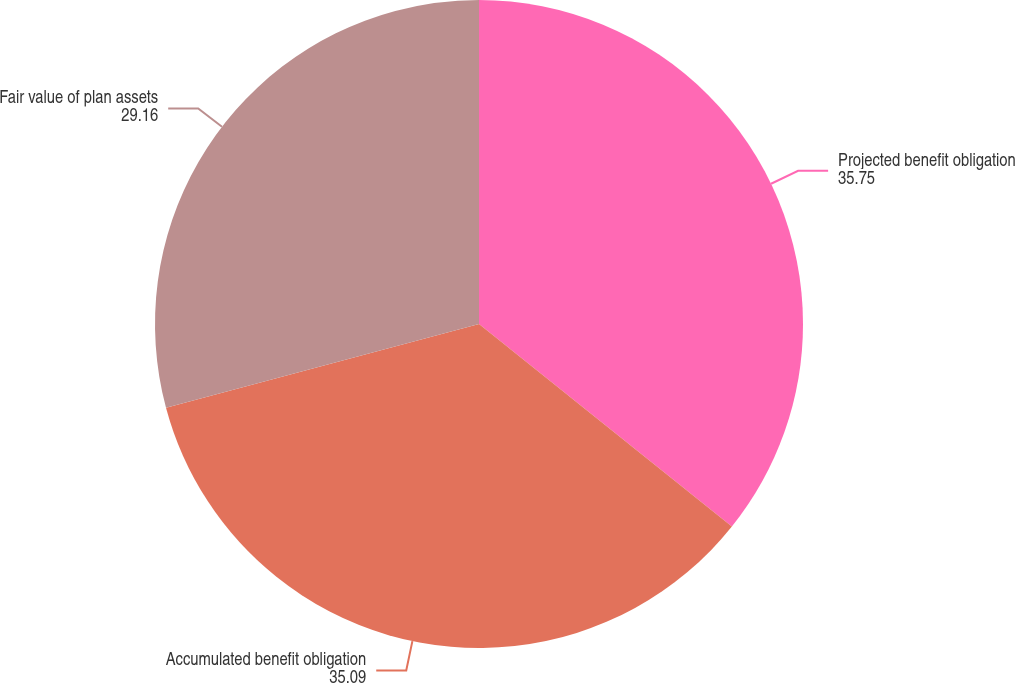Convert chart to OTSL. <chart><loc_0><loc_0><loc_500><loc_500><pie_chart><fcel>Projected benefit obligation<fcel>Accumulated benefit obligation<fcel>Fair value of plan assets<nl><fcel>35.75%<fcel>35.09%<fcel>29.16%<nl></chart> 